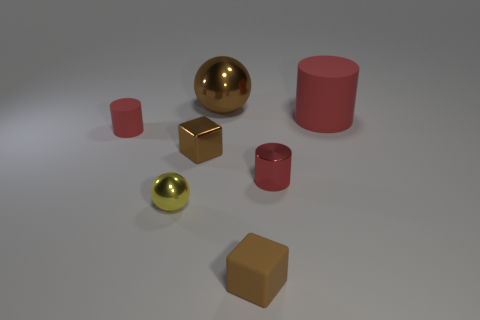Is the color of the big matte thing the same as the tiny rubber cylinder?
Give a very brief answer. Yes. There is a rubber thing that is the same color as the shiny block; what is its shape?
Your answer should be compact. Cube. Do the tiny brown rubber thing and the tiny brown shiny object have the same shape?
Your answer should be very brief. Yes. How many tiny objects are both behind the yellow ball and on the right side of the yellow object?
Ensure brevity in your answer.  2. How many objects are red matte cylinders or small rubber objects that are on the right side of the big brown ball?
Ensure brevity in your answer.  3. Are there more small gray objects than rubber cubes?
Offer a terse response. No. There is a brown object that is to the right of the big brown thing; what is its shape?
Your answer should be compact. Cube. What number of red things have the same shape as the brown rubber object?
Your answer should be compact. 0. How big is the sphere that is in front of the brown metallic object that is behind the small brown shiny cube?
Make the answer very short. Small. What number of red things are either matte objects or big shiny objects?
Provide a succinct answer. 2. 